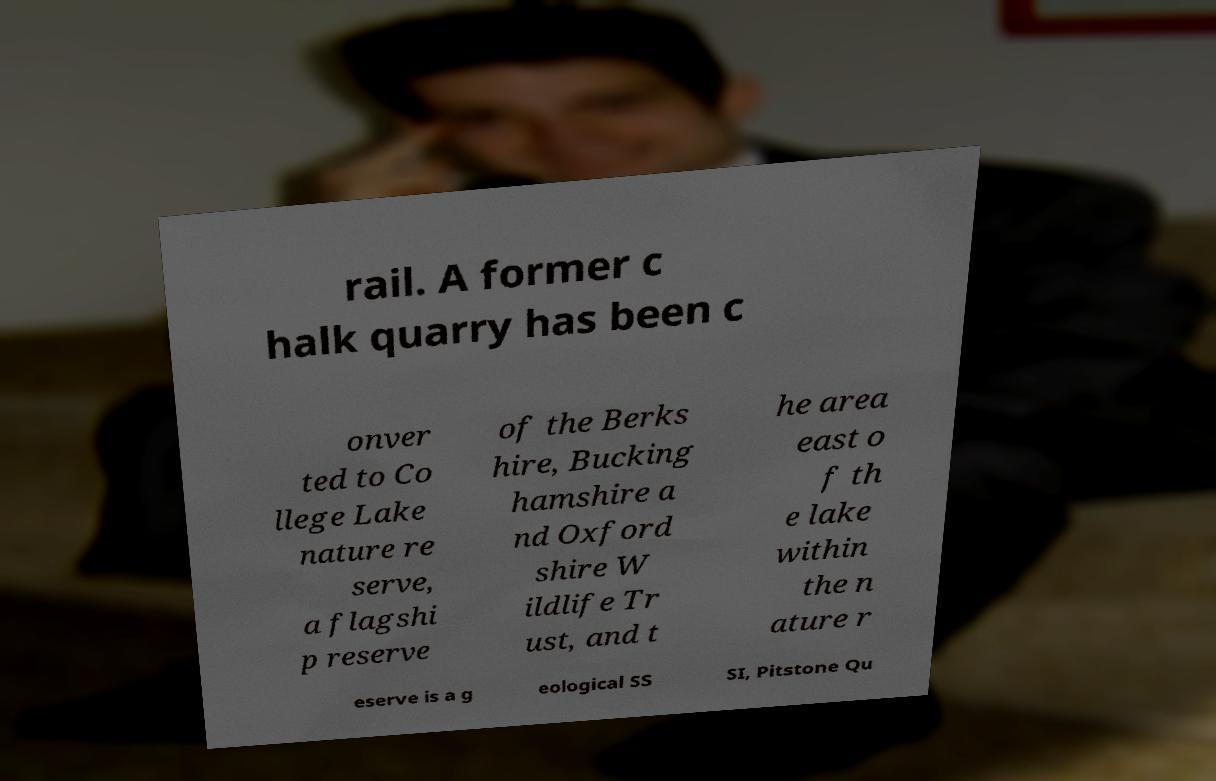For documentation purposes, I need the text within this image transcribed. Could you provide that? rail. A former c halk quarry has been c onver ted to Co llege Lake nature re serve, a flagshi p reserve of the Berks hire, Bucking hamshire a nd Oxford shire W ildlife Tr ust, and t he area east o f th e lake within the n ature r eserve is a g eological SS SI, Pitstone Qu 